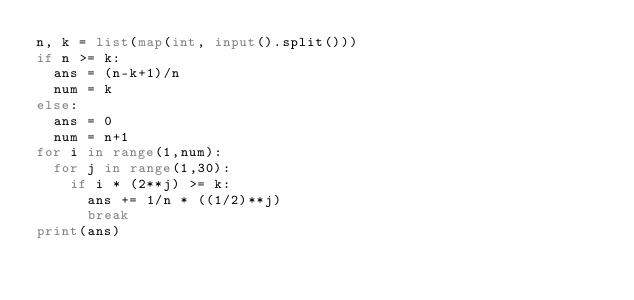<code> <loc_0><loc_0><loc_500><loc_500><_Python_>n, k = list(map(int, input().split()))
if n >= k:
  ans = (n-k+1)/n
  num = k
else:
  ans = 0
  num = n+1
for i in range(1,num):
  for j in range(1,30):
    if i * (2**j) >= k:
      ans += 1/n * ((1/2)**j)
      break
print(ans)</code> 